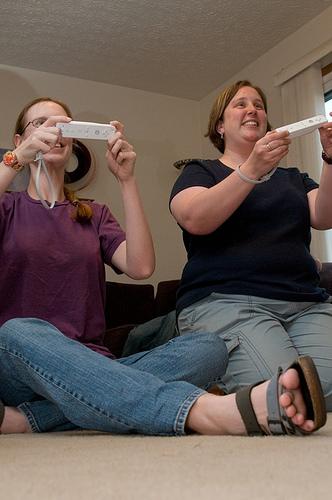What game system are they using?
Be succinct. Wii. What kind of shoes is the woman wearing?
Keep it brief. Sandals. Are they taking pictures?
Concise answer only. No. 